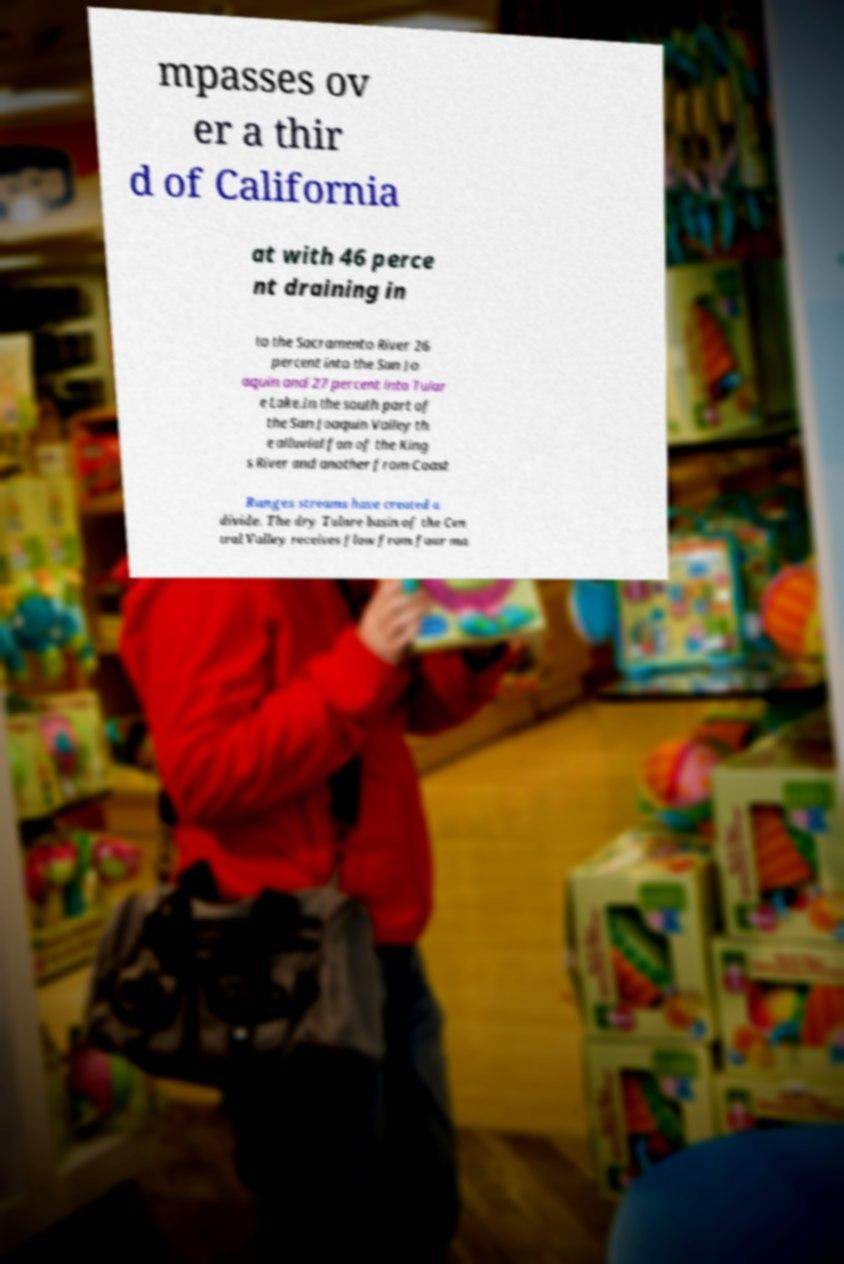Can you accurately transcribe the text from the provided image for me? mpasses ov er a thir d of California at with 46 perce nt draining in to the Sacramento River 26 percent into the San Jo aquin and 27 percent into Tular e Lake.In the south part of the San Joaquin Valley th e alluvial fan of the King s River and another from Coast Ranges streams have created a divide. The dry Tulare basin of the Cen tral Valley receives flow from four ma 